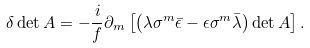<formula> <loc_0><loc_0><loc_500><loc_500>\delta \det A = - \frac { i } { f } \partial _ { m } \left [ \left ( \lambda \sigma ^ { m } \bar { \epsilon } - \epsilon \sigma ^ { m } \bar { \lambda } \right ) \det A \right ] .</formula> 